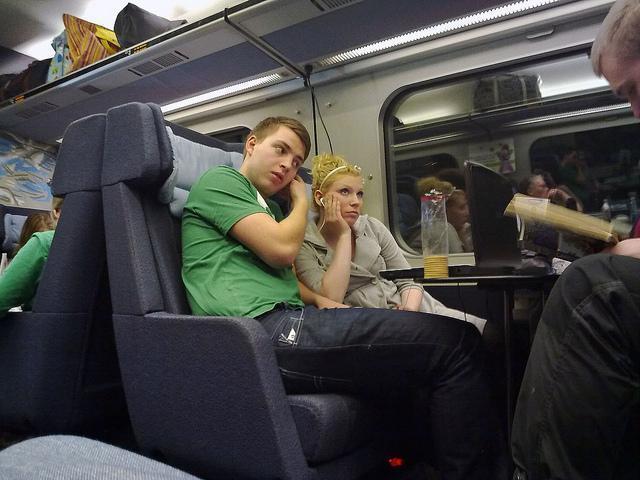How many people are there?
Give a very brief answer. 4. How many bottles are in the picture?
Give a very brief answer. 1. 